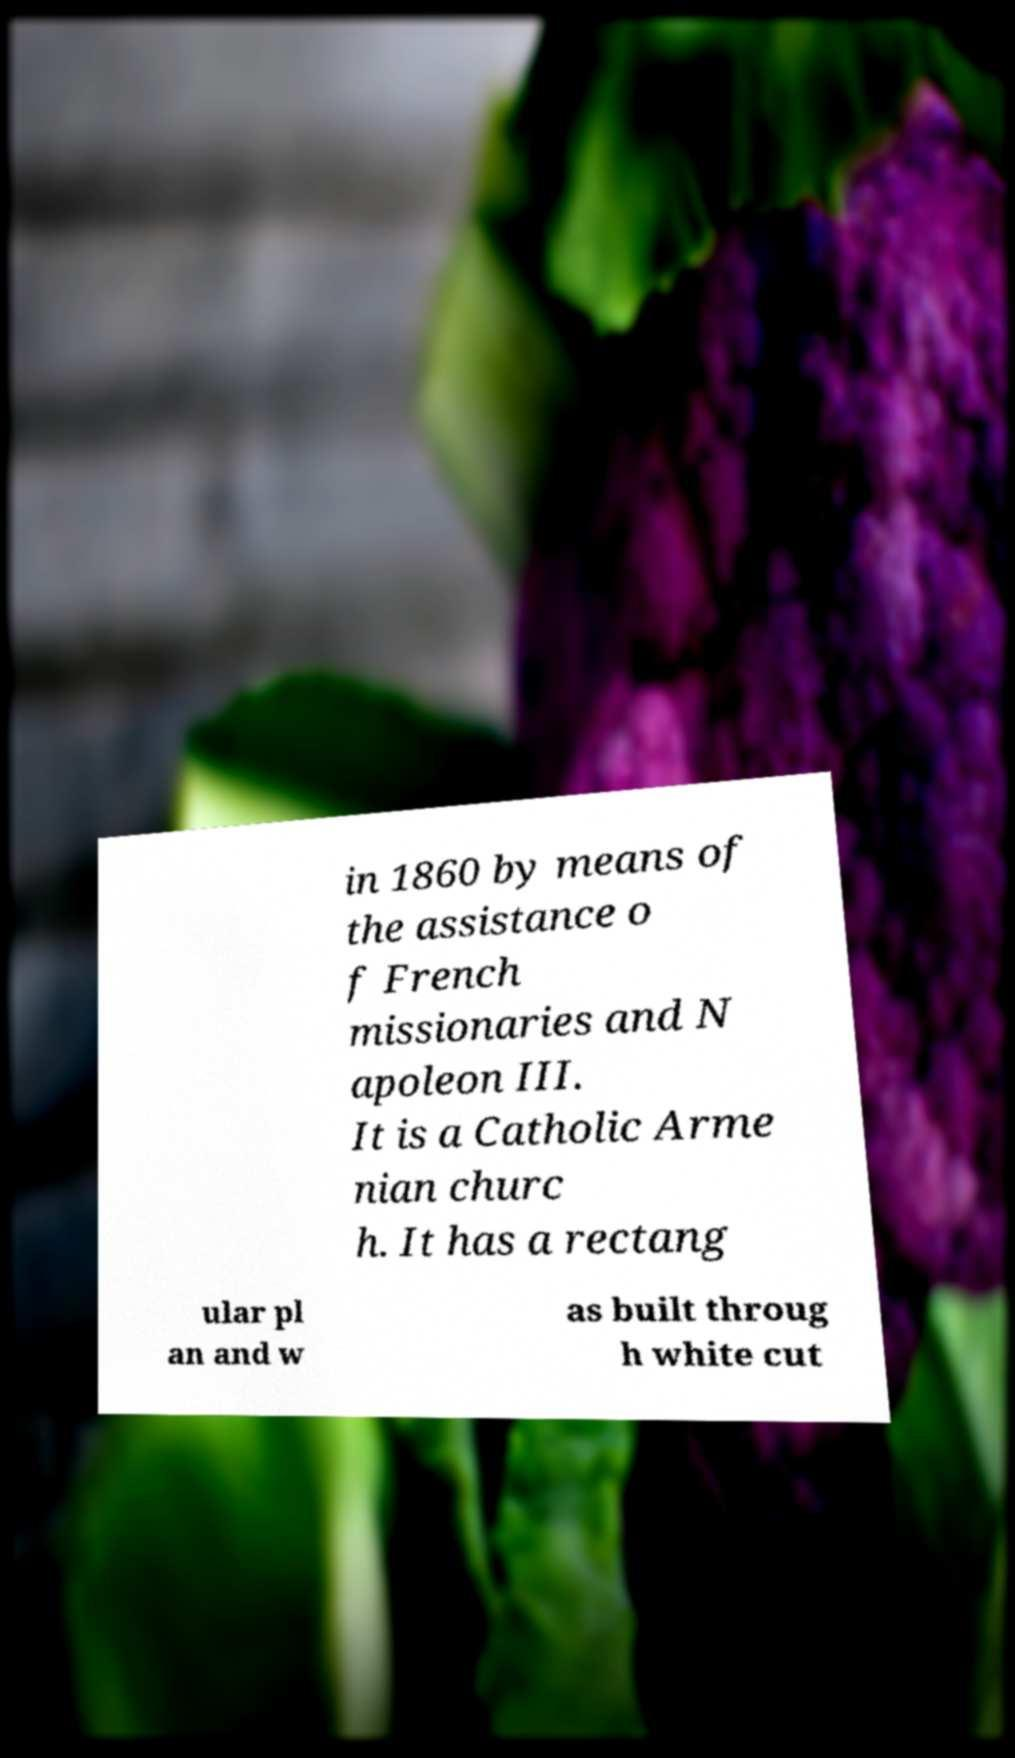For documentation purposes, I need the text within this image transcribed. Could you provide that? in 1860 by means of the assistance o f French missionaries and N apoleon III. It is a Catholic Arme nian churc h. It has a rectang ular pl an and w as built throug h white cut 